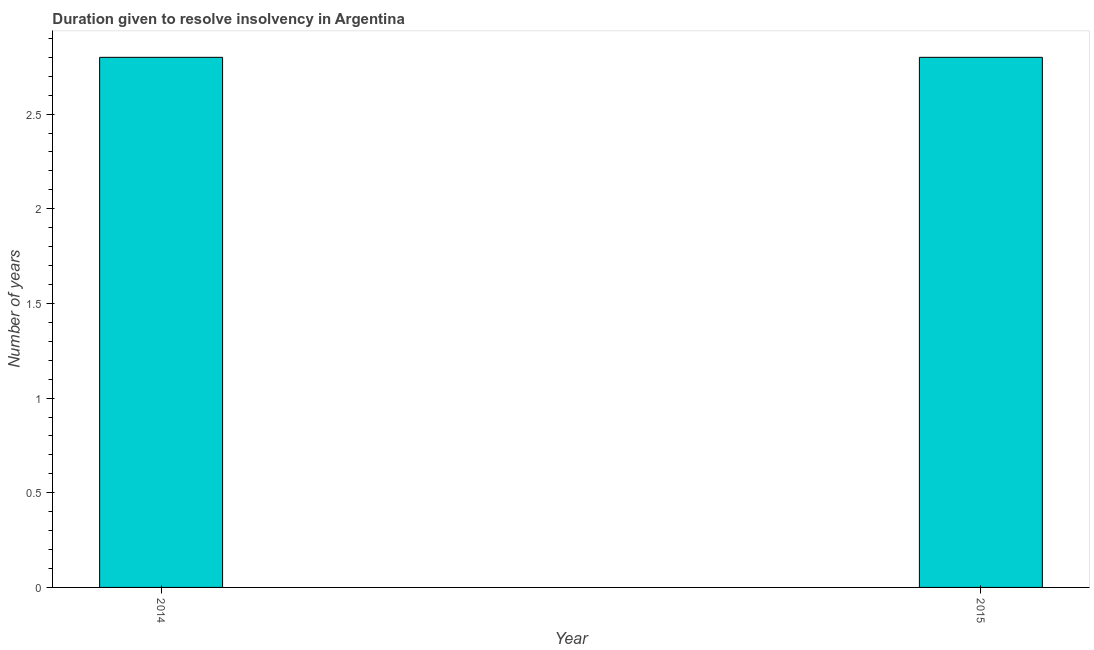Does the graph contain any zero values?
Make the answer very short. No. Does the graph contain grids?
Keep it short and to the point. No. What is the title of the graph?
Your answer should be very brief. Duration given to resolve insolvency in Argentina. What is the label or title of the Y-axis?
Offer a terse response. Number of years. What is the number of years to resolve insolvency in 2014?
Your answer should be very brief. 2.8. Across all years, what is the maximum number of years to resolve insolvency?
Your answer should be very brief. 2.8. In which year was the number of years to resolve insolvency maximum?
Keep it short and to the point. 2014. In which year was the number of years to resolve insolvency minimum?
Your answer should be very brief. 2014. What is the average number of years to resolve insolvency per year?
Your answer should be compact. 2.8. What is the median number of years to resolve insolvency?
Make the answer very short. 2.8. What is the ratio of the number of years to resolve insolvency in 2014 to that in 2015?
Provide a short and direct response. 1. Is the number of years to resolve insolvency in 2014 less than that in 2015?
Provide a succinct answer. No. In how many years, is the number of years to resolve insolvency greater than the average number of years to resolve insolvency taken over all years?
Give a very brief answer. 0. How many bars are there?
Provide a succinct answer. 2. 